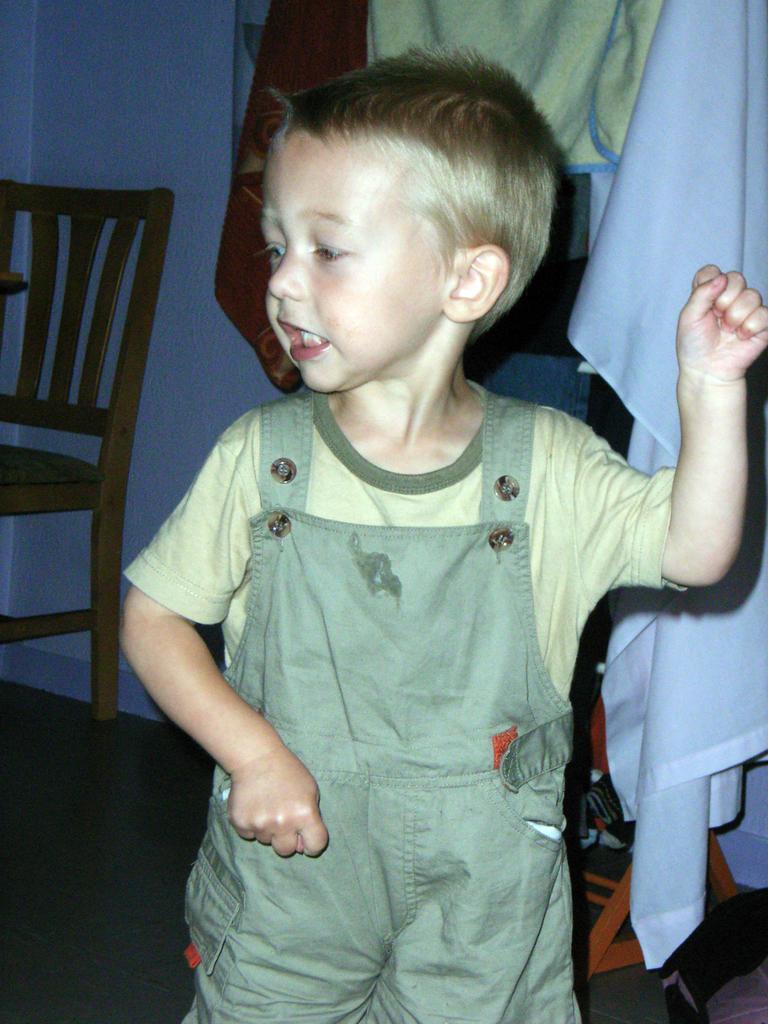Could you give a brief overview of what you see in this image? In this image I can see a boy is standing. In the background I can see clothes and a chair. 